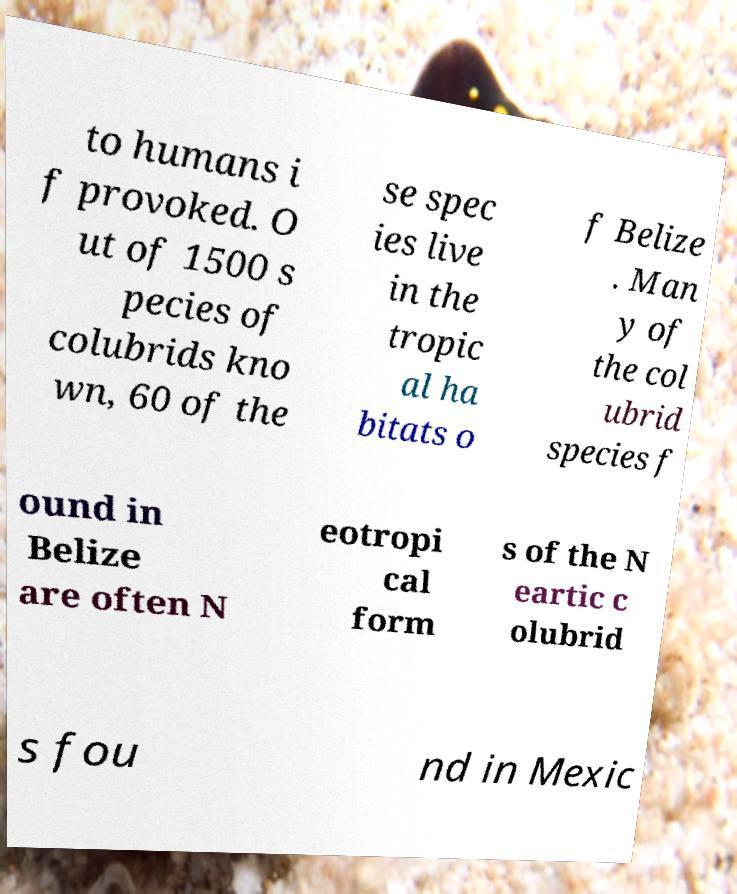Can you read and provide the text displayed in the image?This photo seems to have some interesting text. Can you extract and type it out for me? to humans i f provoked. O ut of 1500 s pecies of colubrids kno wn, 60 of the se spec ies live in the tropic al ha bitats o f Belize . Man y of the col ubrid species f ound in Belize are often N eotropi cal form s of the N eartic c olubrid s fou nd in Mexic 